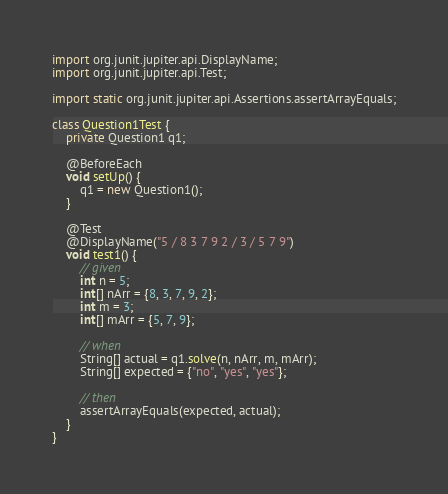Convert code to text. <code><loc_0><loc_0><loc_500><loc_500><_Java_>import org.junit.jupiter.api.DisplayName;
import org.junit.jupiter.api.Test;

import static org.junit.jupiter.api.Assertions.assertArrayEquals;

class Question1Test {
    private Question1 q1;

    @BeforeEach
    void setUp() {
        q1 = new Question1();
    }

    @Test
    @DisplayName("5 / 8 3 7 9 2 / 3 / 5 7 9")
    void test1() {
        // given
        int n = 5;
        int[] nArr = {8, 3, 7, 9, 2};
        int m = 3;
        int[] mArr = {5, 7, 9};

        // when
        String[] actual = q1.solve(n, nArr, m, mArr);
        String[] expected = {"no", "yes", "yes"};

        // then
        assertArrayEquals(expected, actual);
    }
}
</code> 